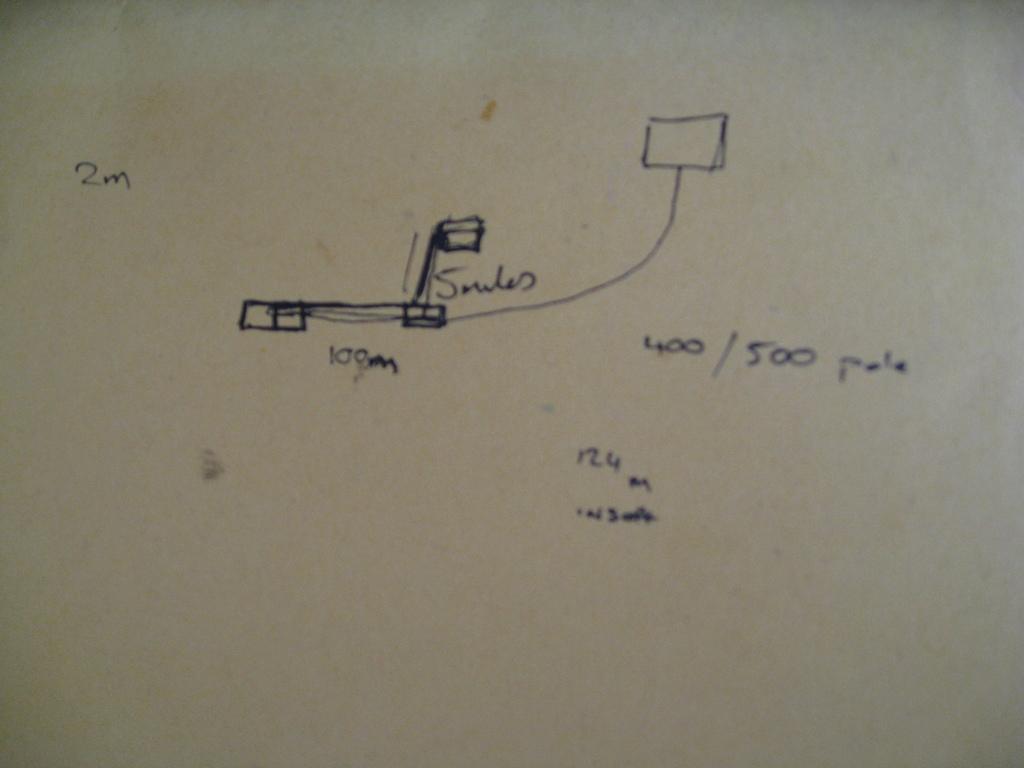What is the number on the right of the white board?
Your answer should be compact. 500. What is the measurement on the left?
Make the answer very short. 2m. 